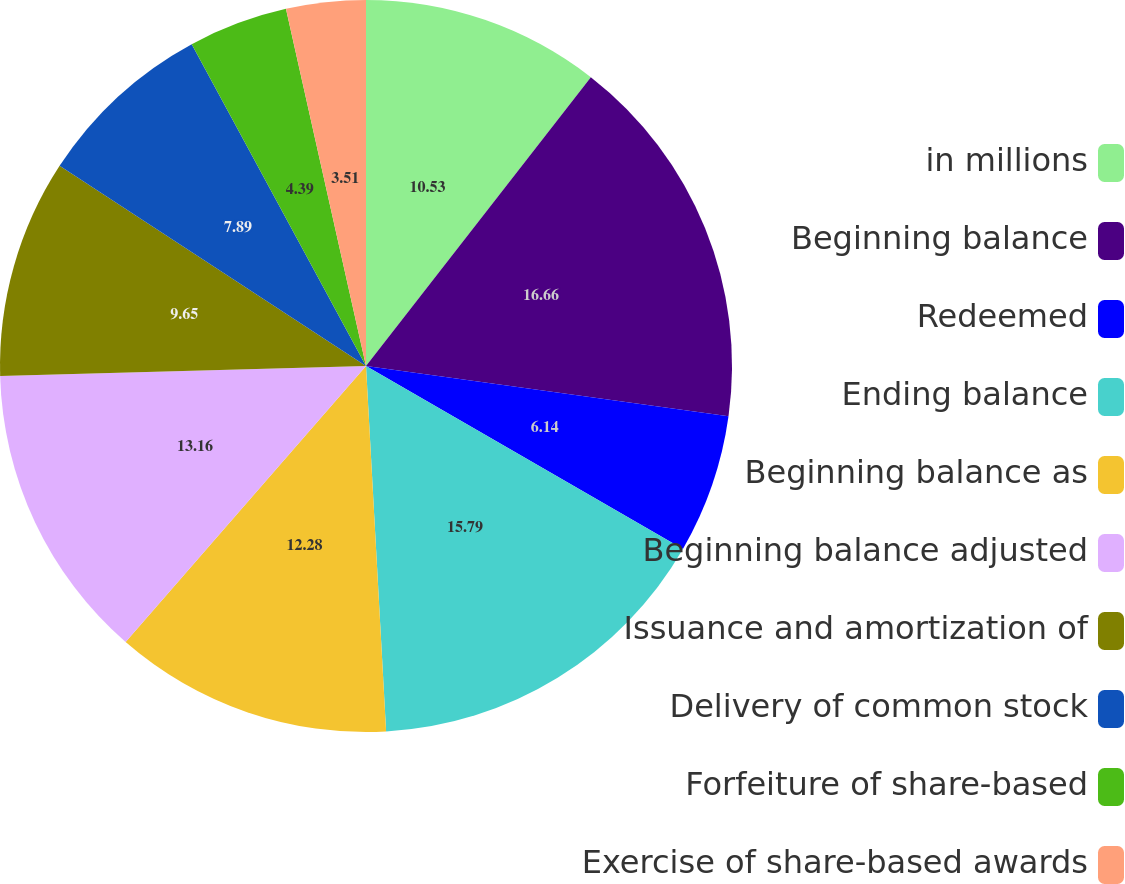<chart> <loc_0><loc_0><loc_500><loc_500><pie_chart><fcel>in millions<fcel>Beginning balance<fcel>Redeemed<fcel>Ending balance<fcel>Beginning balance as<fcel>Beginning balance adjusted<fcel>Issuance and amortization of<fcel>Delivery of common stock<fcel>Forfeiture of share-based<fcel>Exercise of share-based awards<nl><fcel>10.53%<fcel>16.67%<fcel>6.14%<fcel>15.79%<fcel>12.28%<fcel>13.16%<fcel>9.65%<fcel>7.89%<fcel>4.39%<fcel>3.51%<nl></chart> 